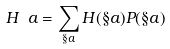Convert formula to latex. <formula><loc_0><loc_0><loc_500><loc_500>H _ { \ } a = \sum _ { \S a } H ( \S a ) P ( \S a )</formula> 